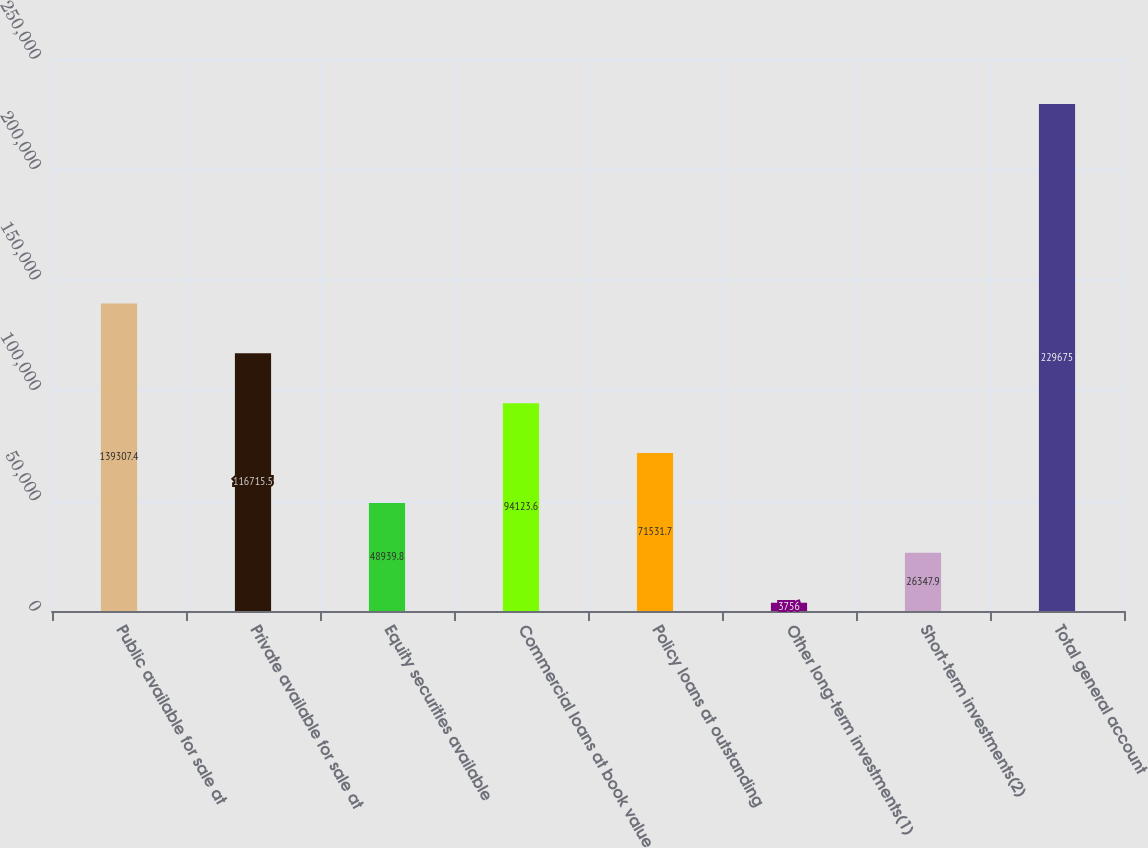Convert chart to OTSL. <chart><loc_0><loc_0><loc_500><loc_500><bar_chart><fcel>Public available for sale at<fcel>Private available for sale at<fcel>Equity securities available<fcel>Commercial loans at book value<fcel>Policy loans at outstanding<fcel>Other long-term investments(1)<fcel>Short-term investments(2)<fcel>Total general account<nl><fcel>139307<fcel>116716<fcel>48939.8<fcel>94123.6<fcel>71531.7<fcel>3756<fcel>26347.9<fcel>229675<nl></chart> 